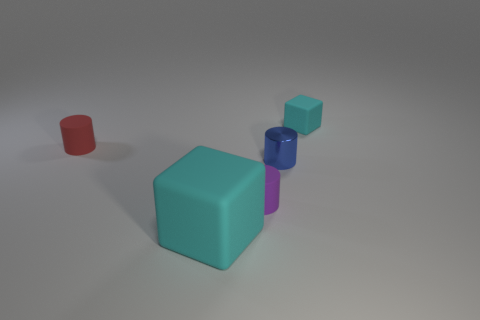There is a red object that is the same material as the large cyan cube; what size is it?
Give a very brief answer. Small. What shape is the cyan object that is left of the tiny cyan matte object?
Your answer should be very brief. Cube. What size is the metallic object that is the same shape as the tiny purple rubber thing?
Your answer should be very brief. Small. There is a cyan rubber block to the right of the cyan thing that is on the left side of the small purple cylinder; how many matte cubes are right of it?
Provide a short and direct response. 0. Is the number of blocks that are behind the small cyan matte block the same as the number of metal cylinders?
Keep it short and to the point. No. What number of cylinders are either small purple matte things or tiny red objects?
Provide a short and direct response. 2. Does the large block have the same color as the shiny thing?
Keep it short and to the point. No. Are there an equal number of objects that are to the left of the red object and small blue things that are on the right side of the small cyan matte thing?
Ensure brevity in your answer.  Yes. What color is the metallic cylinder?
Offer a terse response. Blue. How many things are either matte blocks that are in front of the tiny red thing or cubes?
Provide a short and direct response. 2. 